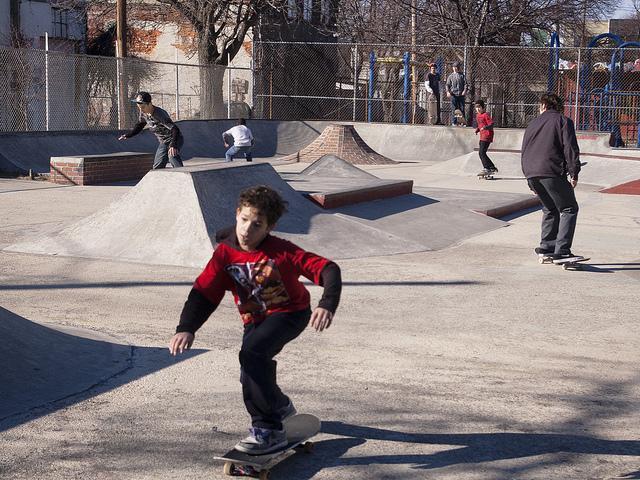How many people are in the picture?
Give a very brief answer. 3. How many bears are in the water?
Give a very brief answer. 0. 